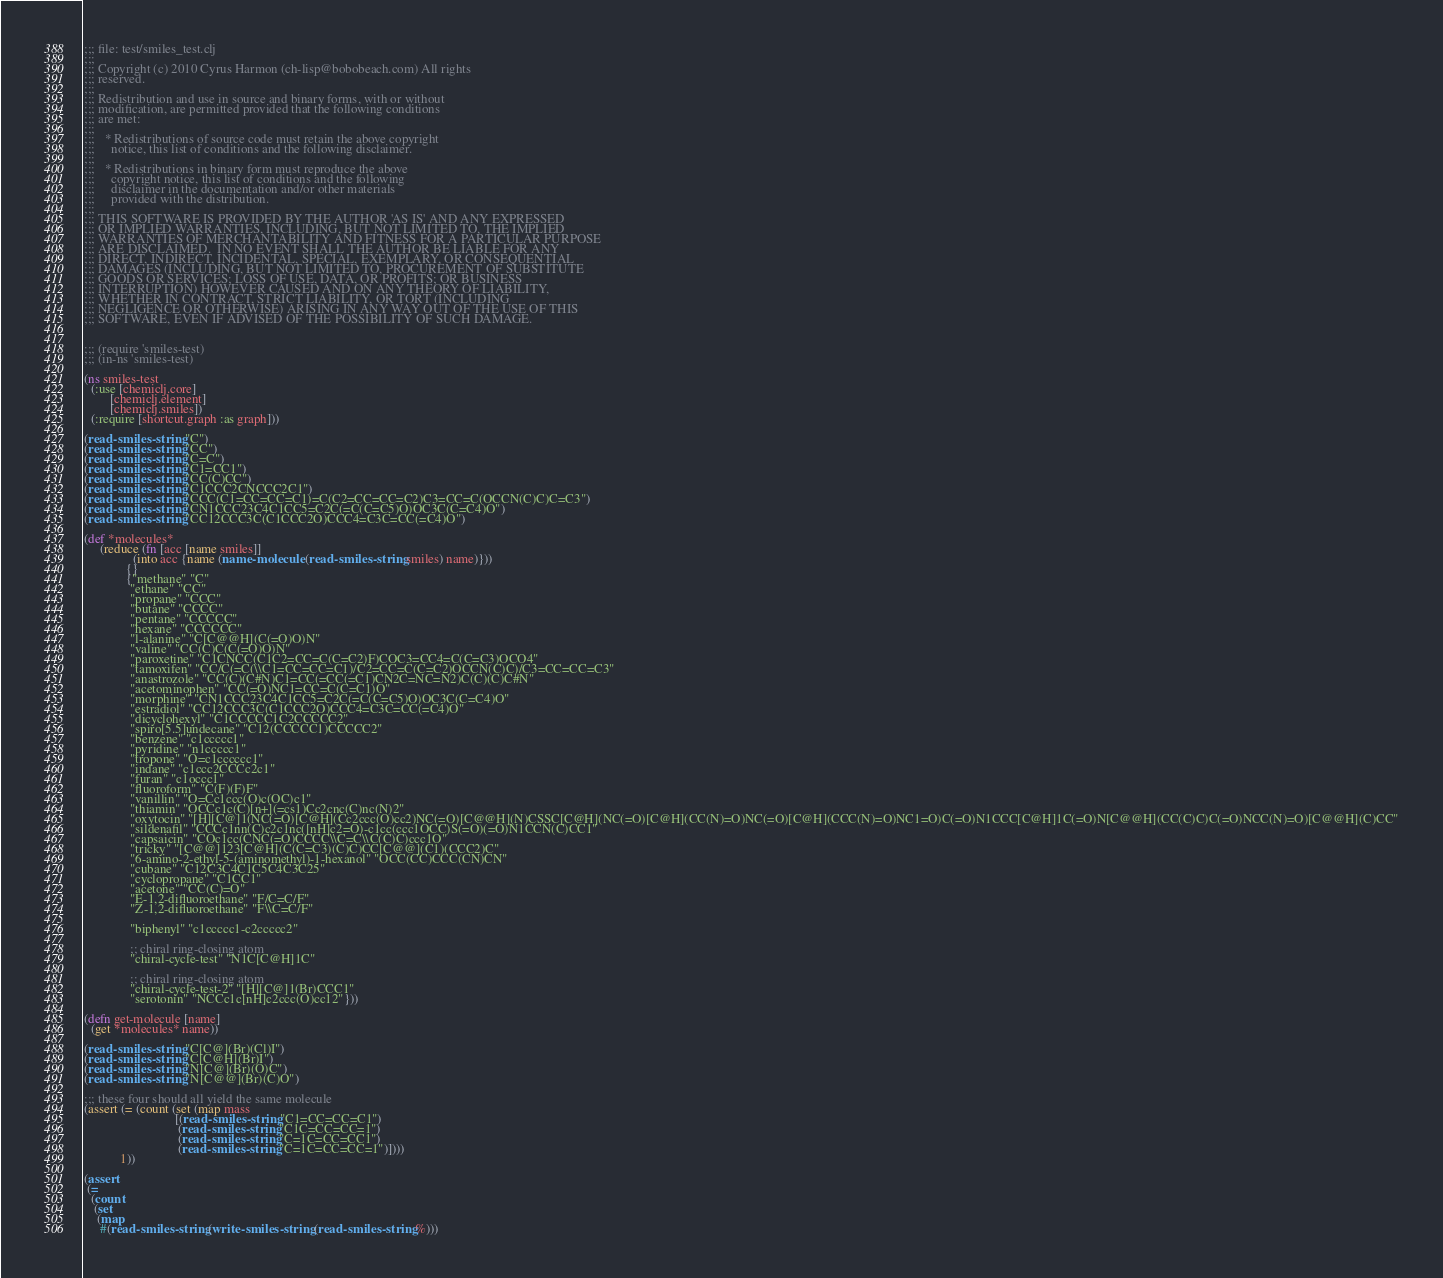<code> <loc_0><loc_0><loc_500><loc_500><_Clojure_>;;; file: test/smiles_test.clj
;;;
;;; Copyright (c) 2010 Cyrus Harmon (ch-lisp@bobobeach.com) All rights
;;; reserved.
;;;
;;; Redistribution and use in source and binary forms, with or without
;;; modification, are permitted provided that the following conditions
;;; are met:
;;;
;;;   * Redistributions of source code must retain the above copyright
;;;     notice, this list of conditions and the following disclaimer.
;;;
;;;   * Redistributions in binary form must reproduce the above
;;;     copyright notice, this list of conditions and the following
;;;     disclaimer in the documentation and/or other materials
;;;     provided with the distribution.
;;;
;;; THIS SOFTWARE IS PROVIDED BY THE AUTHOR 'AS IS' AND ANY EXPRESSED
;;; OR IMPLIED WARRANTIES, INCLUDING, BUT NOT LIMITED TO, THE IMPLIED
;;; WARRANTIES OF MERCHANTABILITY AND FITNESS FOR A PARTICULAR PURPOSE
;;; ARE DISCLAIMED.  IN NO EVENT SHALL THE AUTHOR BE LIABLE FOR ANY
;;; DIRECT, INDIRECT, INCIDENTAL, SPECIAL, EXEMPLARY, OR CONSEQUENTIAL
;;; DAMAGES (INCLUDING, BUT NOT LIMITED TO, PROCUREMENT OF SUBSTITUTE
;;; GOODS OR SERVICES; LOSS OF USE, DATA, OR PROFITS; OR BUSINESS
;;; INTERRUPTION) HOWEVER CAUSED AND ON ANY THEORY OF LIABILITY,
;;; WHETHER IN CONTRACT, STRICT LIABILITY, OR TORT (INCLUDING
;;; NEGLIGENCE OR OTHERWISE) ARISING IN ANY WAY OUT OF THE USE OF THIS
;;; SOFTWARE, EVEN IF ADVISED OF THE POSSIBILITY OF SUCH DAMAGE.


;;; (require 'smiles-test)
;;; (in-ns 'smiles-test)

(ns smiles-test
  (:use [chemiclj.core]
        [chemiclj.element]
        [chemiclj.smiles])
  (:require [shortcut.graph :as graph]))

(read-smiles-string "C")
(read-smiles-string "CC")
(read-smiles-string "C=C")
(read-smiles-string "C1=CC1")
(read-smiles-string "CC(C)CC")
(read-smiles-string "C1CCC2CNCCC2C1")
(read-smiles-string "CCC(C1=CC=CC=C1)=C(C2=CC=CC=C2)C3=CC=C(OCCN(C)C)C=C3")
(read-smiles-string "CN1CCC23C4C1CC5=C2C(=C(C=C5)O)OC3C(C=C4)O")
(read-smiles-string "CC12CCC3C(C1CCC2O)CCC4=C3C=CC(=C4)O")

(def *molecules*
     (reduce (fn [acc [name smiles]]
               (into acc {name (name-molecule (read-smiles-string smiles) name)}))
             {}
             {"methane" "C"
              "ethane" "CC"
              "propane" "CCC"
              "butane" "CCCC"
              "pentane" "CCCCC"
              "hexane" "CCCCCC"
              "l-alanine" "C[C@@H](C(=O)O)N"
              "valine" "CC(C)C(C(=O)O)N"
              "paroxetine" "C1CNCC(C1C2=CC=C(C=C2)F)COC3=CC4=C(C=C3)OCO4"
              "tamoxifen" "CC/C(=C(\\C1=CC=CC=C1)/C2=CC=C(C=C2)OCCN(C)C)/C3=CC=CC=C3"
              "anastrozole" "CC(C)(C#N)C1=CC(=CC(=C1)CN2C=NC=N2)C(C)(C)C#N"
              "acetominophen" "CC(=O)NC1=CC=C(C=C1)O"
              "morphine" "CN1CCC23C4C1CC5=C2C(=C(C=C5)O)OC3C(C=C4)O"
              "estradiol" "CC12CCC3C(C1CCC2O)CCC4=C3C=CC(=C4)O"
              "dicyclohexyl" "C1CCCCC1C2CCCCC2"
              "spiro[5.5]undecane" "C12(CCCCC1)CCCCC2"
              "benzene" "c1ccccc1"
              "pyridine" "n1ccccc1"
              "tropone" "O=c1cccccc1"
              "indane" "c1ccc2CCCc2c1"
              "furan" "c1occc1"
              "fluoroform" "C(F)(F)F"
              "vanillin" "O=Cc1ccc(O)c(OC)c1"
              "thiamin" "OCCc1c(C)[n+](=cs1)Cc2cnc(C)nc(N)2"
              "oxytocin" "[H][C@]1(NC(=O)[C@H](Cc2ccc(O)cc2)NC(=O)[C@@H](N)CSSC[C@H](NC(=O)[C@H](CC(N)=O)NC(=O)[C@H](CCC(N)=O)NC1=O)C(=O)N1CCC[C@H]1C(=O)N[C@@H](CC(C)C)C(=O)NCC(N)=O)[C@@H](C)CC"
              "sildenafil" "CCCc1nn(C)c2c1nc([nH]c2=O)-c1cc(ccc1OCC)S(=O)(=O)N1CCN(C)CC1"
              "capsaicin" "COc1cc(CNC(=O)CCCC\\C=C\\C(C)C)ccc1O"
              "tricky" "[C@@]123[C@H](C(C=C3)(C)C)CC[C@@](C1)(CCC2)C"
              "6-amino-2-ethyl-5-(aminomethyl)-1-hexanol" "OCC(CC)CCC(CN)CN"
              "cubane" "C12C3C4C1C5C4C3C25"
              "cyclopropane" "C1CC1"
              "acetone" "CC(C)=O"
              "E-1,2-difluoroethane" "F/C=C/F"
              "Z-1,2-difluoroethane" "F\\C=C/F"

              "biphenyl" "c1ccccc1-c2ccccc2"

              ;; chiral ring-closing atom
              "chiral-cycle-test" "N1C[C@H]1C"

              ;; chiral ring-closing atom
              "chiral-cycle-test-2" "[H][C@]1(Br)CCC1"
              "serotonin" "NCCc1c[nH]c2ccc(O)cc12"})) 

(defn get-molecule [name]
  (get *molecules* name))

(read-smiles-string "C[C@](Br)(Cl)I") 
(read-smiles-string "C[C@H](Br)I")
(read-smiles-string "N[C@](Br)(O)C")
(read-smiles-string "N[C@@](Br)(C)O")

;;; these four should all yield the same molecule
(assert (= (count (set (map mass
                            [(read-smiles-string "C1=CC=CC=C1")
                             (read-smiles-string "C1C=CC=CC=1")
                             (read-smiles-string "C=1C=CC=CC1")
                             (read-smiles-string "C=1C=CC=CC=1")])))
           1))

(assert
 (=
  (count
   (set
    (map
     #(read-smiles-string (write-smiles-string (read-smiles-string %)))</code> 